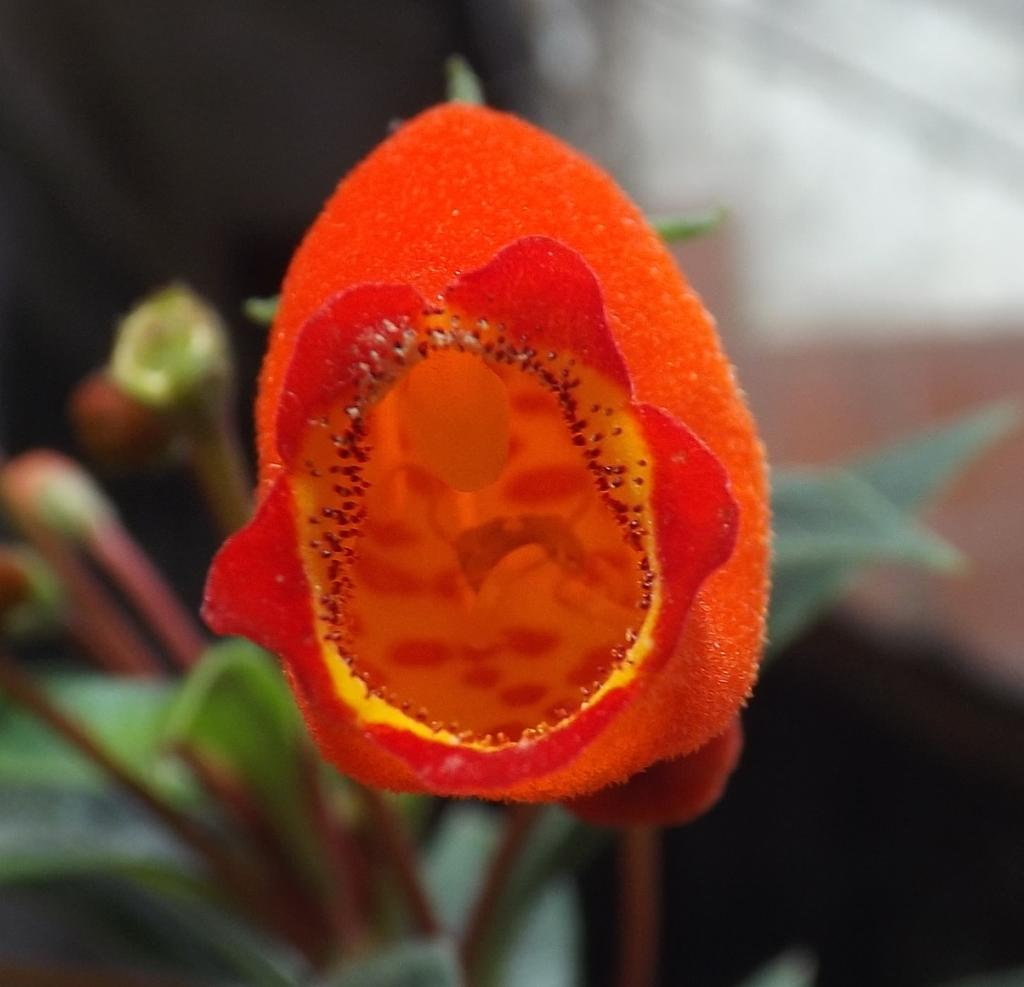What is the main subject of the image? There is a flower in the image. Where is the flower located in the image? The flower is in the center of the image. What type of hat is the flower wearing in the image? There is no hat present in the image, as the main subject is a flower. 